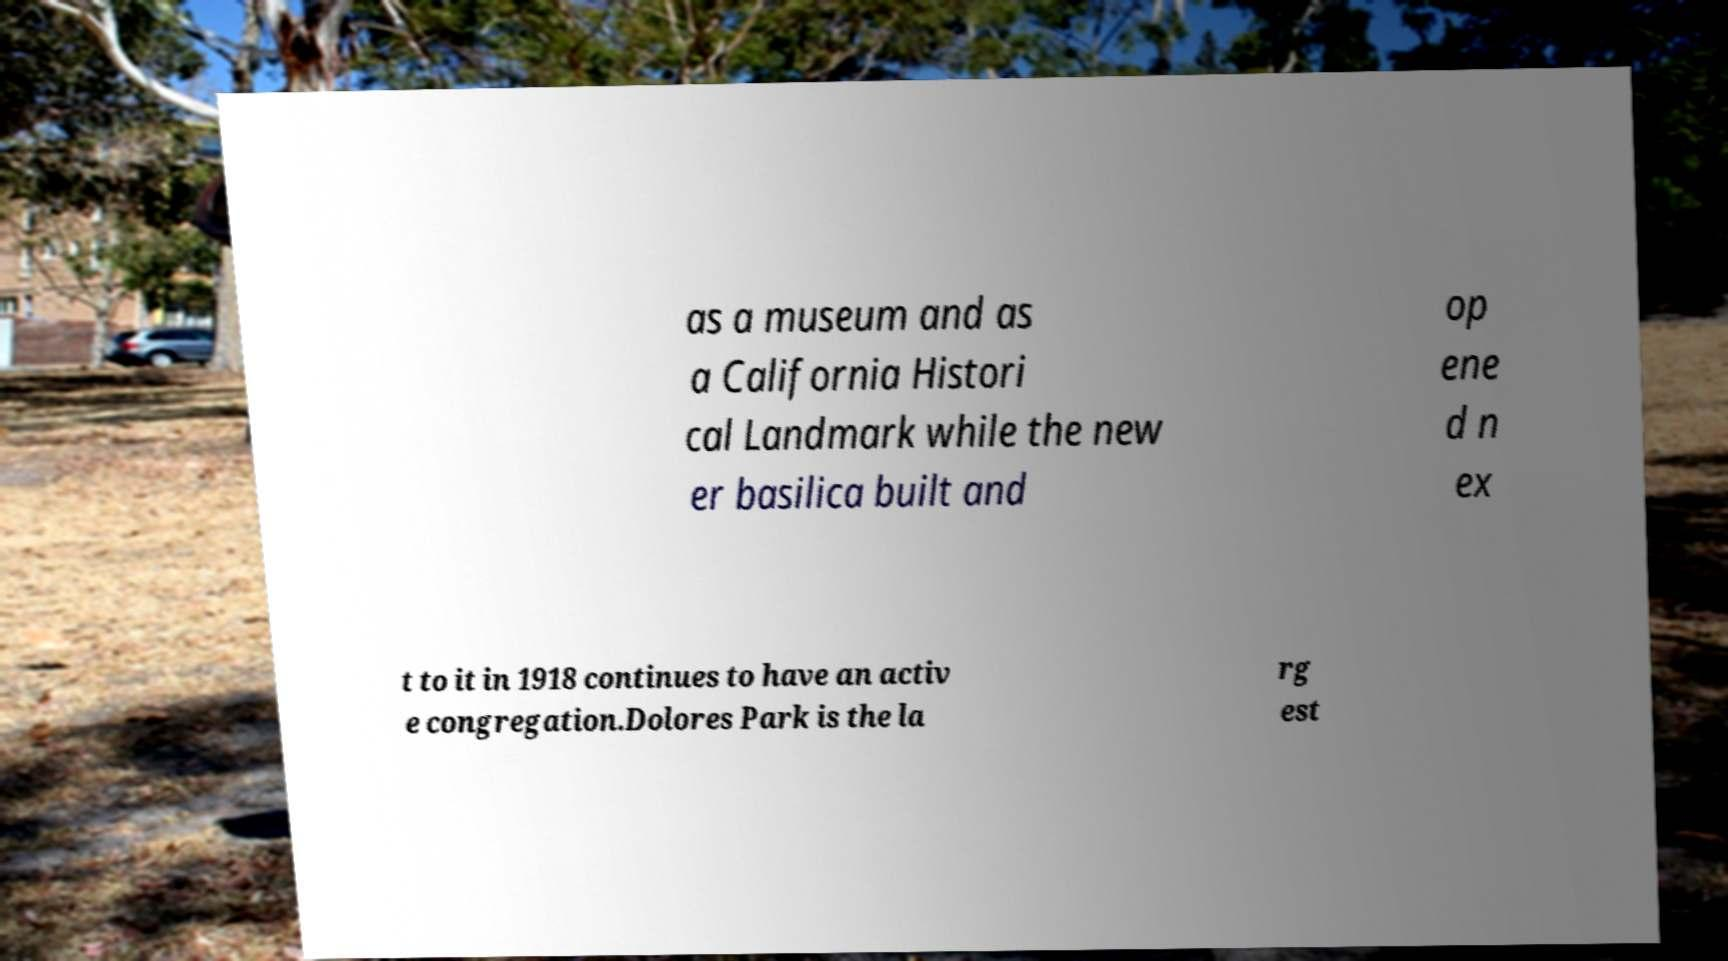Could you assist in decoding the text presented in this image and type it out clearly? as a museum and as a California Histori cal Landmark while the new er basilica built and op ene d n ex t to it in 1918 continues to have an activ e congregation.Dolores Park is the la rg est 